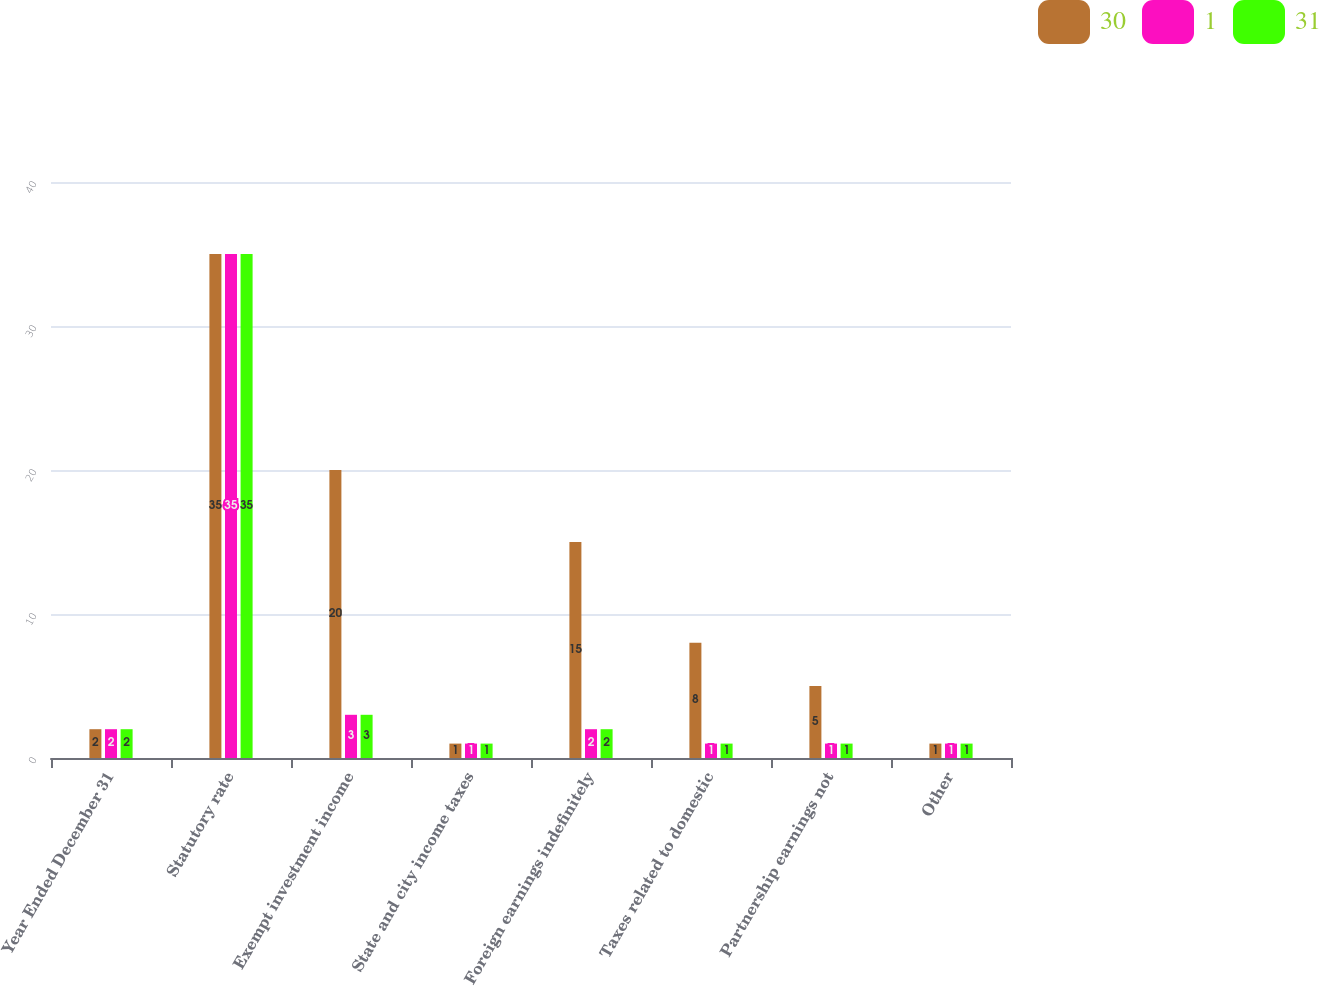Convert chart to OTSL. <chart><loc_0><loc_0><loc_500><loc_500><stacked_bar_chart><ecel><fcel>Year Ended December 31<fcel>Statutory rate<fcel>Exempt investment income<fcel>State and city income taxes<fcel>Foreign earnings indefinitely<fcel>Taxes related to domestic<fcel>Partnership earnings not<fcel>Other<nl><fcel>30<fcel>2<fcel>35<fcel>20<fcel>1<fcel>15<fcel>8<fcel>5<fcel>1<nl><fcel>1<fcel>2<fcel>35<fcel>3<fcel>1<fcel>2<fcel>1<fcel>1<fcel>1<nl><fcel>31<fcel>2<fcel>35<fcel>3<fcel>1<fcel>2<fcel>1<fcel>1<fcel>1<nl></chart> 